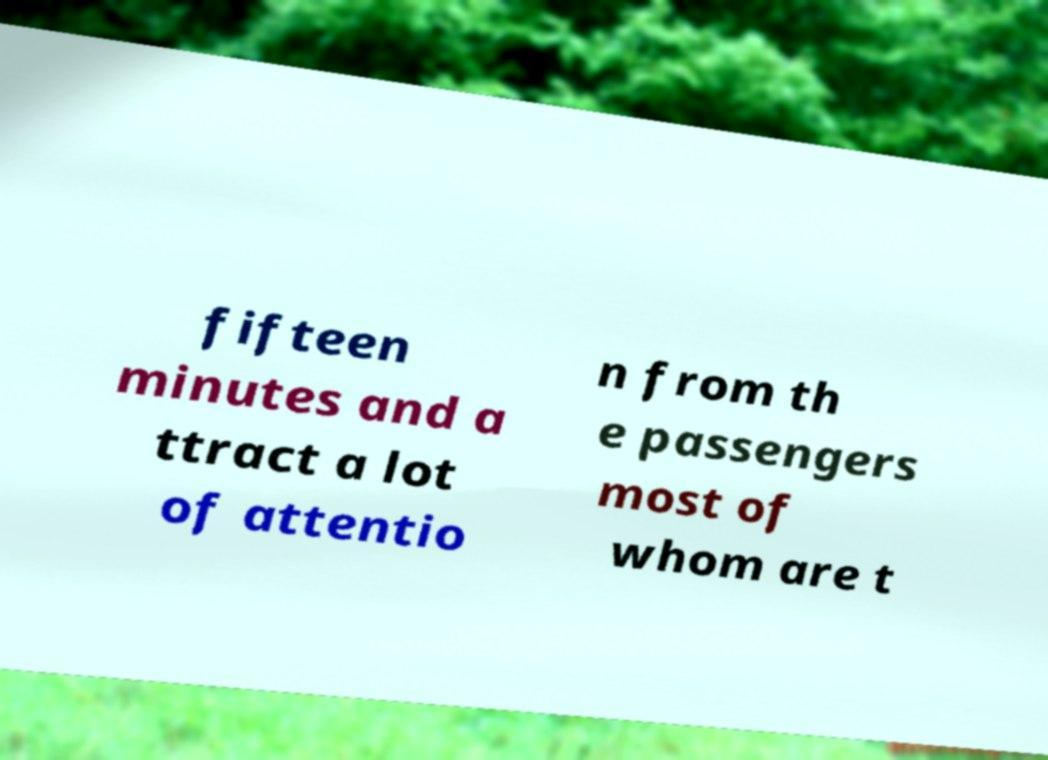Please read and relay the text visible in this image. What does it say? fifteen minutes and a ttract a lot of attentio n from th e passengers most of whom are t 